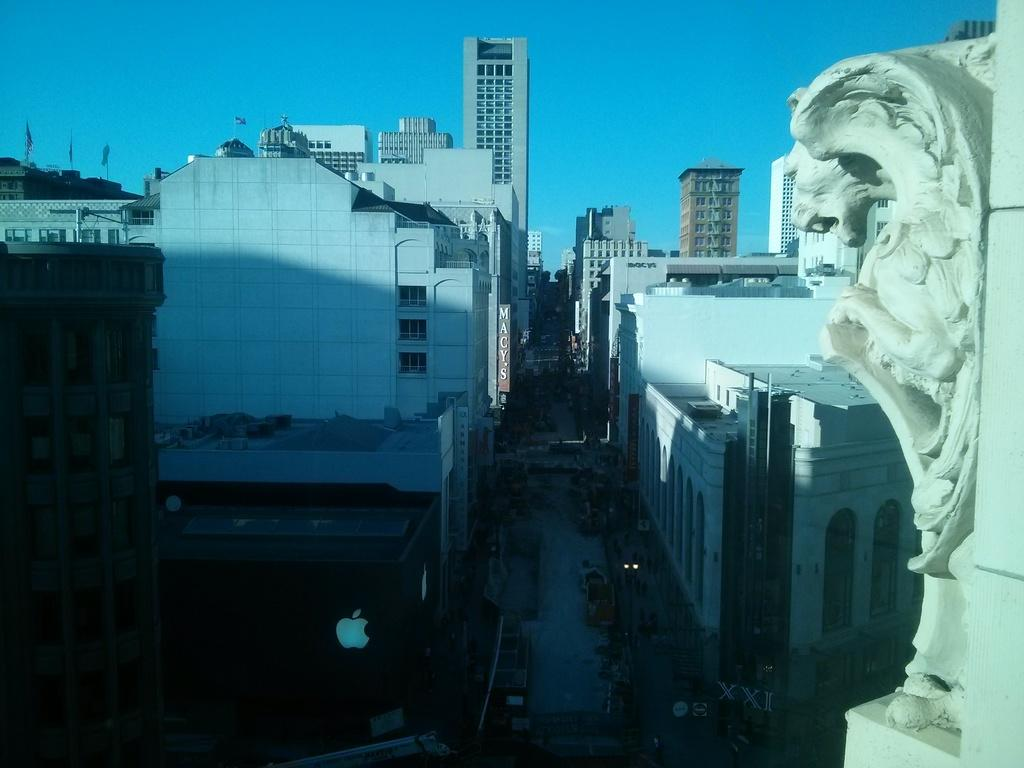What type of structures can be seen in the image? There are buildings in the image. What is located between the buildings? There is a road visible between the buildings. What is visible at the top of the image? The sky is visible at the top of the image. Where is the sculpture located in the image? The sculpture is on the right side of the image, attached to a wall. What type of insect can be seen flying near the sculpture in the image? There are no insects visible in the image, so it is not possible to determine what type of insect might be flying near the sculpture. 